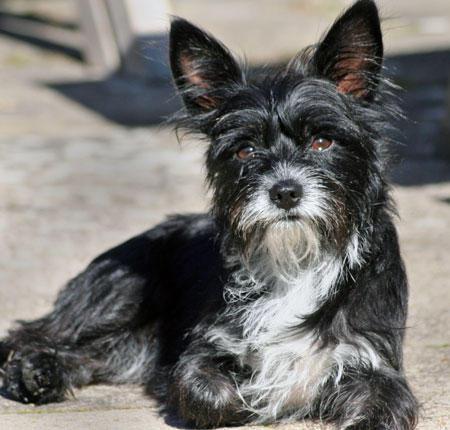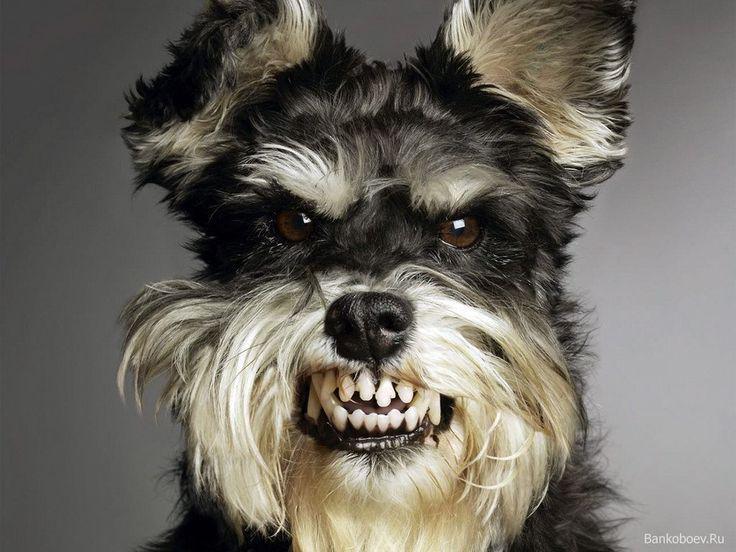The first image is the image on the left, the second image is the image on the right. Examine the images to the left and right. Is the description "There is an expanse of green grass in one dog image." accurate? Answer yes or no. No. The first image is the image on the left, the second image is the image on the right. Examine the images to the left and right. Is the description "There is grass visible on one of the images." accurate? Answer yes or no. No. The first image is the image on the left, the second image is the image on the right. For the images shown, is this caption "In one image there is a dog outside with some grass in the image." true? Answer yes or no. No. The first image is the image on the left, the second image is the image on the right. Analyze the images presented: Is the assertion "There is one image of a mostly black dog and one of at least one gray dog." valid? Answer yes or no. No. 